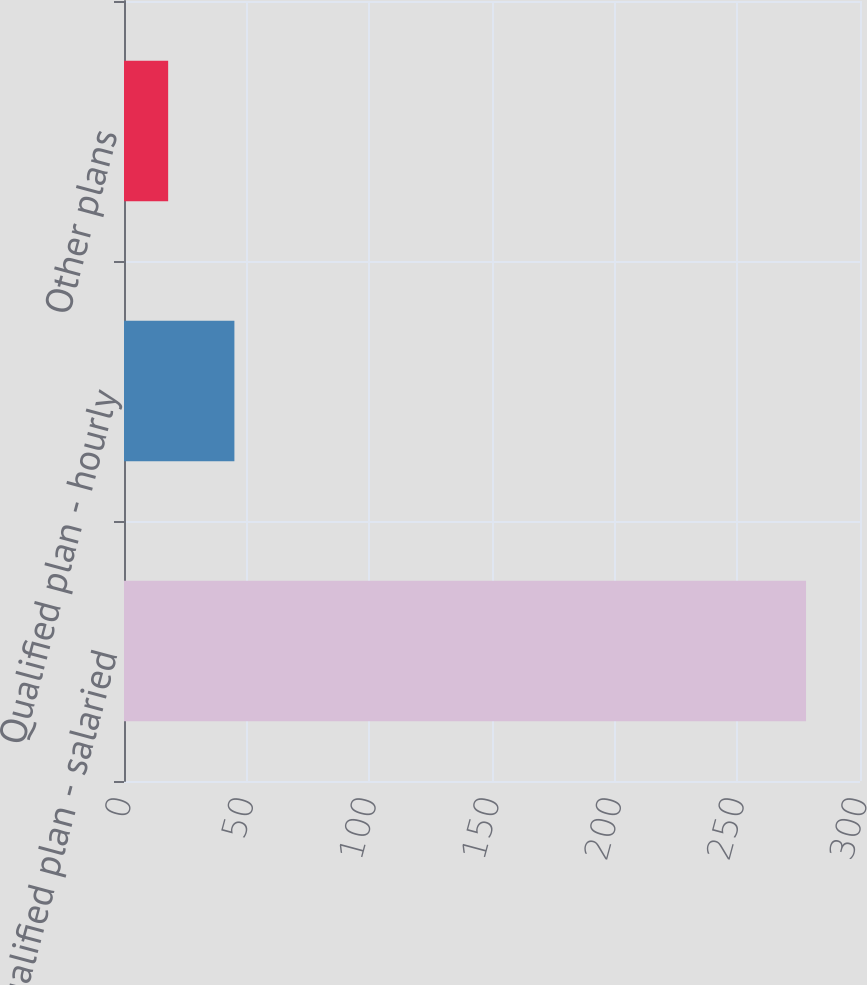Convert chart to OTSL. <chart><loc_0><loc_0><loc_500><loc_500><bar_chart><fcel>Qualified plan - salaried<fcel>Qualified plan - hourly<fcel>Other plans<nl><fcel>278<fcel>45<fcel>18<nl></chart> 